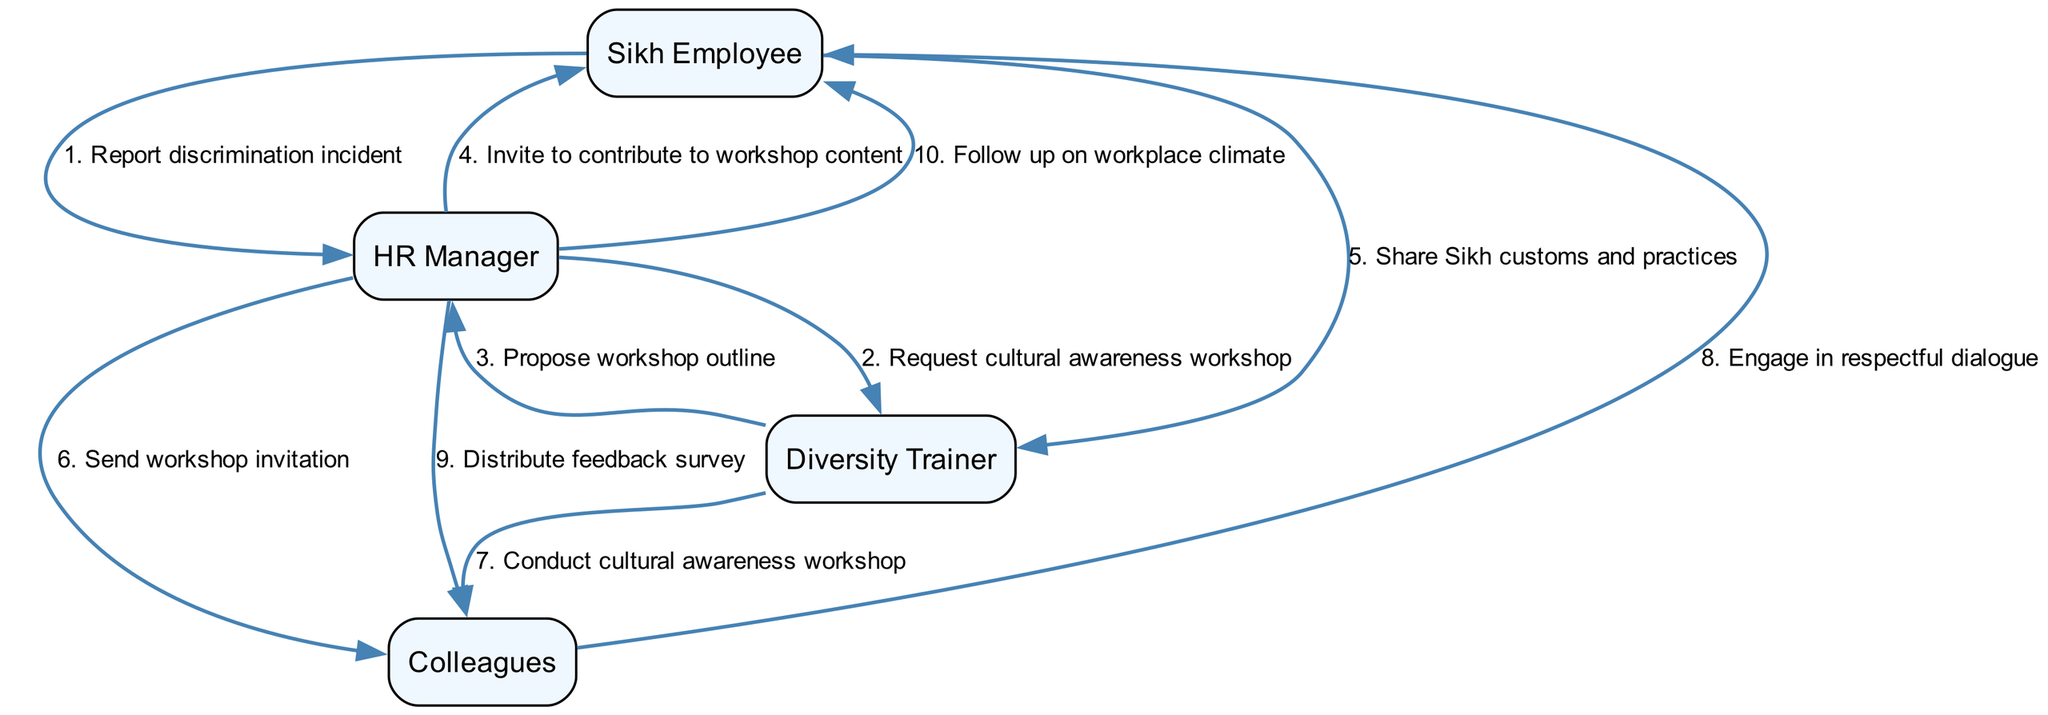What is the first action taken in the sequence? The first action is initiated by the Sikh Employee who reports a discrimination incident to the HR Manager. This is the starting point of the sequence diagram.
Answer: Report discrimination incident How many actors are involved in the sequence? By counting the unique entities listed, there are four actors: Sikh Employee, HR Manager, Diversity Trainer, and Colleagues.
Answer: 4 What action does the Diversity Trainer perform after the HR Manager requests a workshop? After the HR Manager requests a cultural awareness workshop, the Diversity Trainer proposes a workshop outline. This follows directly in the sequence of actions, showing the preparatory phase of the workshop.
Answer: Propose workshop outline Who shares their customs with the Diversity Trainer? The Sikh Employee shares their customs and practices with the Diversity Trainer, providing valuable content for the workshop. This action flows directly from the earlier invitation received from the HR Manager.
Answer: Sikh Employee What is the last action taken towards the Sikh Employee? The last action directed towards the Sikh Employee involves the HR Manager following up on the workplace climate after the workshop has occurred, indicating ongoing support and concern for the employee's experience.
Answer: Follow up on workplace climate How many actions involve the HR Manager directly? By examining the sequence, the HR Manager is involved in five actions, coordinating between the Sikh Employee, Diversity Trainer, and Colleagues throughout the process.
Answer: 5 In which step do colleagues engage in dialogue? The colleagues engage in respectful dialogue following the cultural awareness workshop conducted by the Diversity Trainer, indicating an interactive outcome of the workshop.
Answer: Engage in respectful dialogue Which actor sends a workshop invitation? The HR Manager is responsible for sending the workshop invitation to colleagues, facilitating their participation in the cultural awareness effort.
Answer: HR Manager What happens immediately after the Diversity Trainer proposes the workshop outline? Immediately after the Diversity Trainer proposes the workshop outline, the HR Manager invites the Sikh Employee to contribute to the workshop content, indicating a collaborative effort.
Answer: Invite to contribute to workshop content 